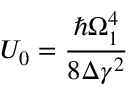Convert formula to latex. <formula><loc_0><loc_0><loc_500><loc_500>U _ { 0 } = \frac { \hbar { \Omega } _ { 1 } ^ { 4 } } { 8 \Delta \gamma ^ { 2 } }</formula> 